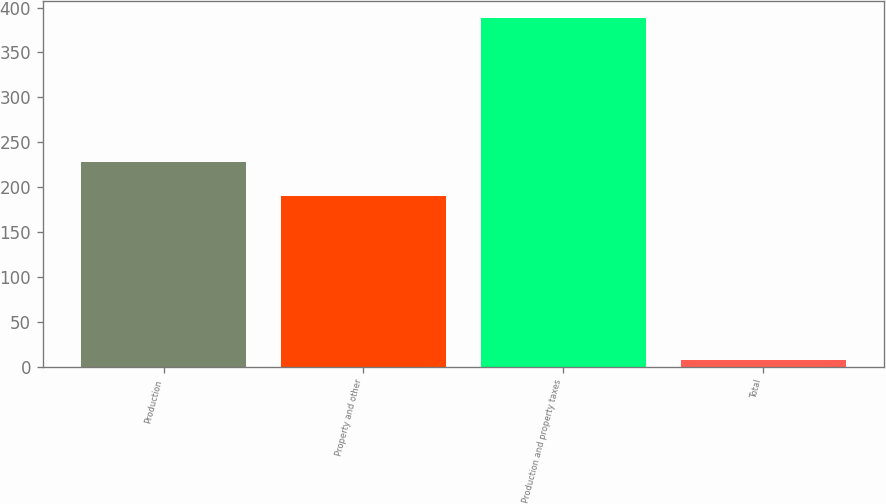Convert chart to OTSL. <chart><loc_0><loc_0><loc_500><loc_500><bar_chart><fcel>Production<fcel>Property and other<fcel>Production and property taxes<fcel>Total<nl><fcel>228.08<fcel>190<fcel>388<fcel>7.2<nl></chart> 